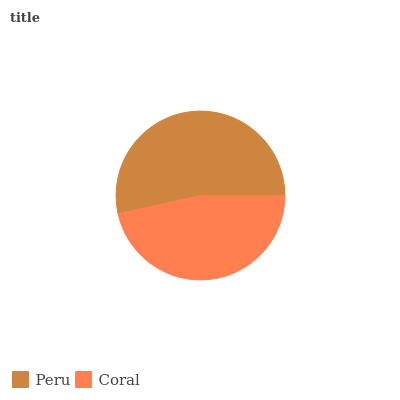Is Coral the minimum?
Answer yes or no. Yes. Is Peru the maximum?
Answer yes or no. Yes. Is Coral the maximum?
Answer yes or no. No. Is Peru greater than Coral?
Answer yes or no. Yes. Is Coral less than Peru?
Answer yes or no. Yes. Is Coral greater than Peru?
Answer yes or no. No. Is Peru less than Coral?
Answer yes or no. No. Is Peru the high median?
Answer yes or no. Yes. Is Coral the low median?
Answer yes or no. Yes. Is Coral the high median?
Answer yes or no. No. Is Peru the low median?
Answer yes or no. No. 